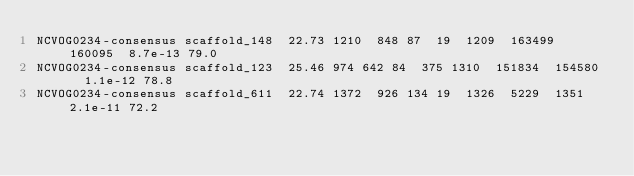Convert code to text. <code><loc_0><loc_0><loc_500><loc_500><_SQL_>NCVOG0234-consensus	scaffold_148	22.73	1210	848	87	19	1209	163499	160095	8.7e-13	79.0
NCVOG0234-consensus	scaffold_123	25.46	974	642	84	375	1310	151834	154580	1.1e-12	78.8
NCVOG0234-consensus	scaffold_611	22.74	1372	926	134	19	1326	5229	1351	2.1e-11	72.2</code> 